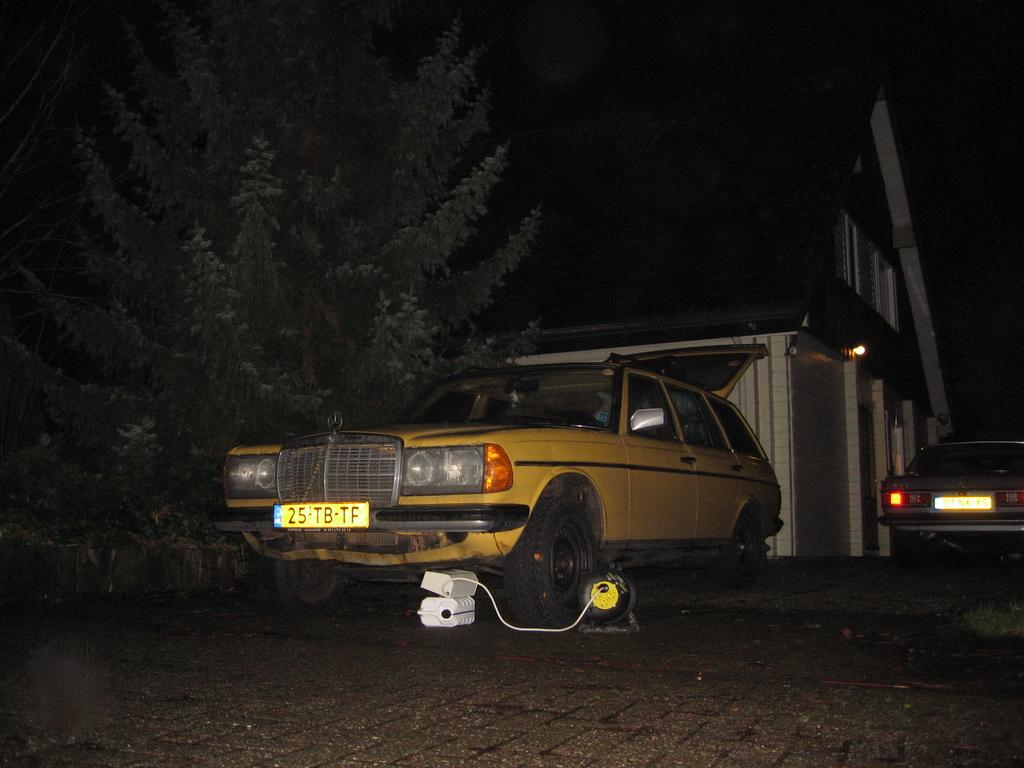What types of vehicles can be seen in the image? There are vehicles in the image, but the specific types cannot be determined from the provided facts. What is visible in the background of the image? There is a building, trees, and other objects in the background of the image. What is at the bottom of the image? There is a road at the bottom of the image. What type of linen is being used to stitch the plough in the image? There is no linen, stitching, or plough present in the image. 